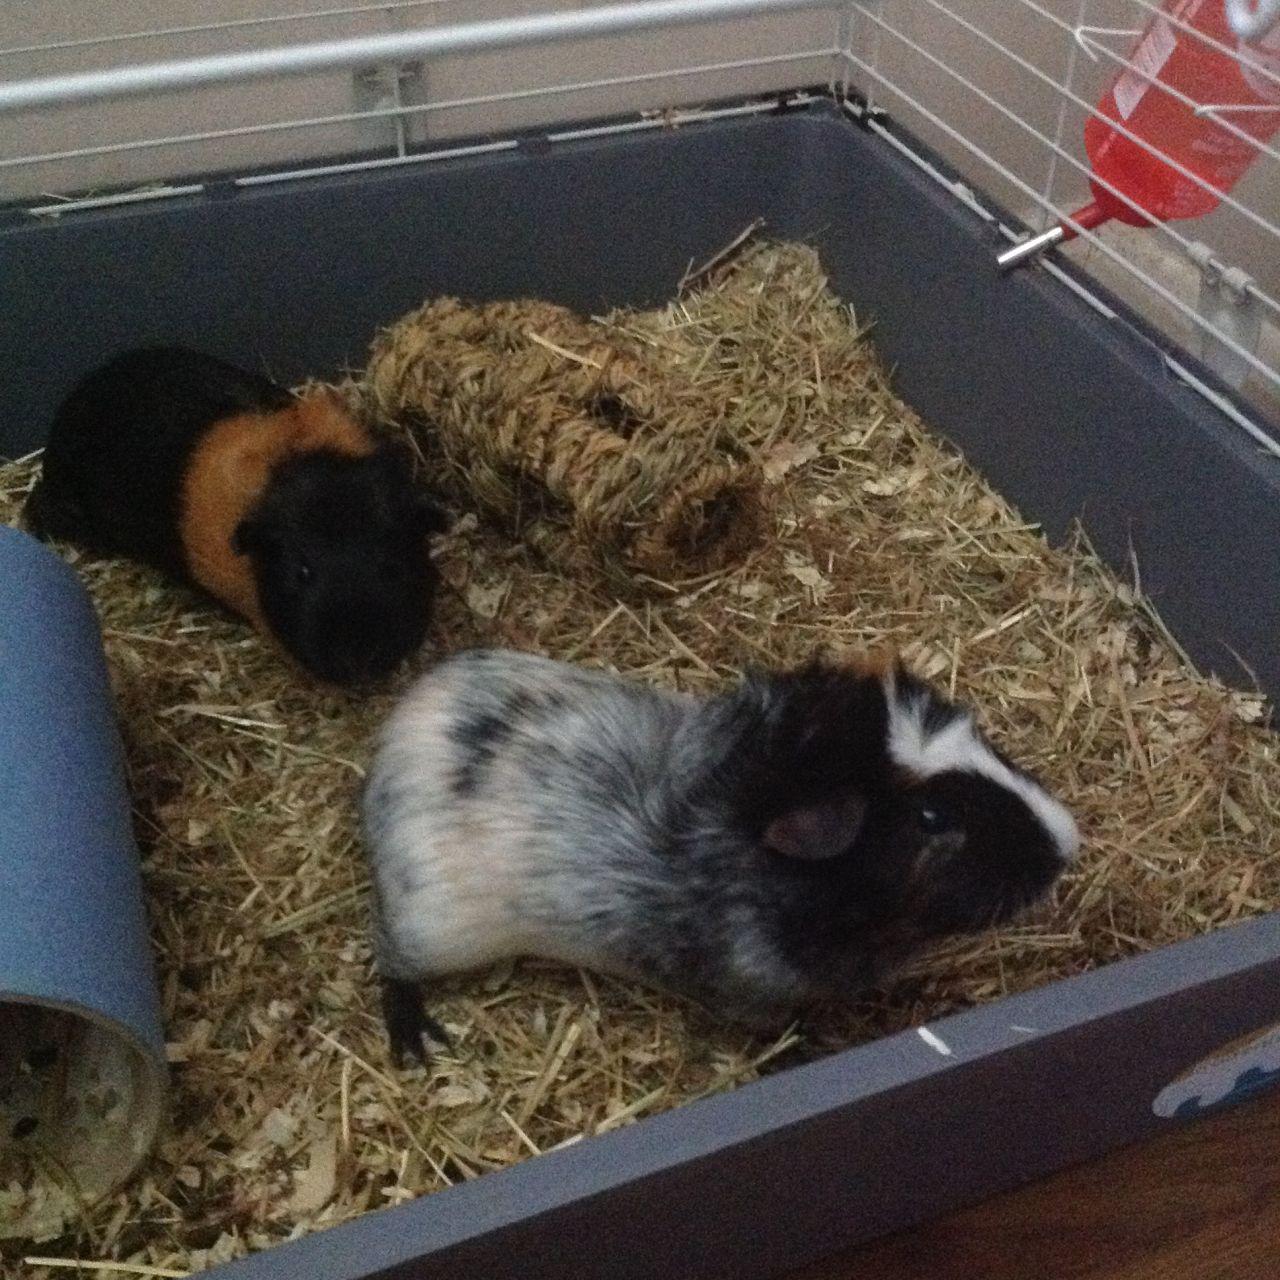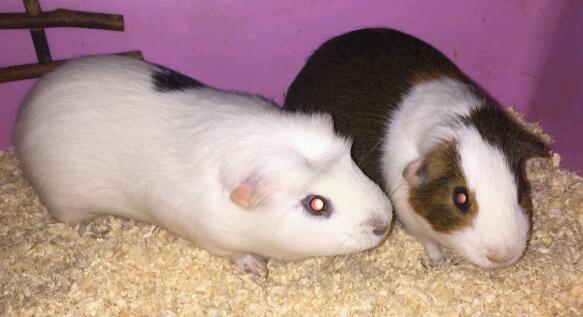The first image is the image on the left, the second image is the image on the right. Assess this claim about the two images: "Each image shows two pet rodents on shredded-type bedding.". Correct or not? Answer yes or no. Yes. 